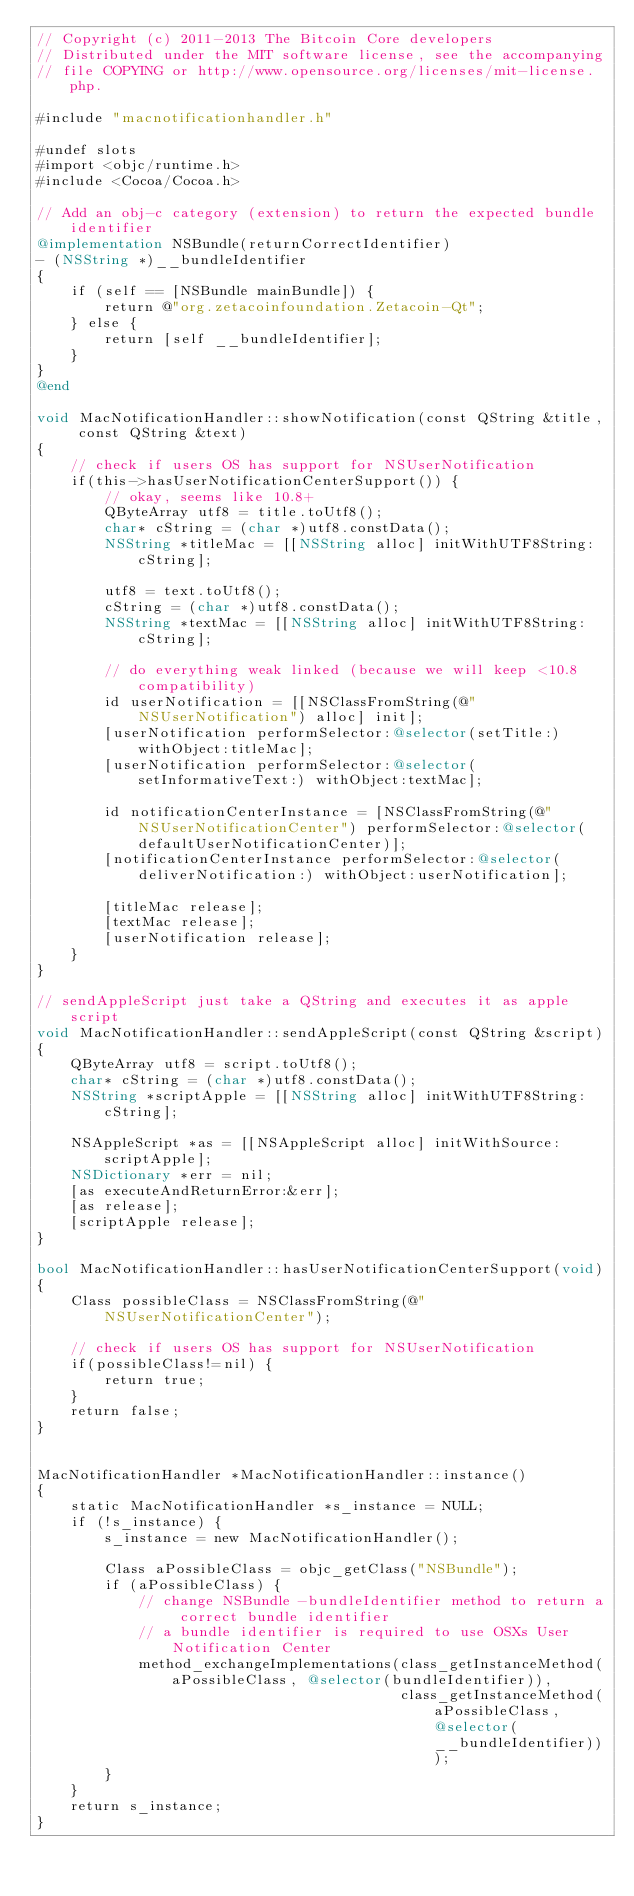Convert code to text. <code><loc_0><loc_0><loc_500><loc_500><_ObjectiveC_>// Copyright (c) 2011-2013 The Bitcoin Core developers
// Distributed under the MIT software license, see the accompanying
// file COPYING or http://www.opensource.org/licenses/mit-license.php.

#include "macnotificationhandler.h"

#undef slots
#import <objc/runtime.h>
#include <Cocoa/Cocoa.h>

// Add an obj-c category (extension) to return the expected bundle identifier
@implementation NSBundle(returnCorrectIdentifier)
- (NSString *)__bundleIdentifier
{
    if (self == [NSBundle mainBundle]) {
        return @"org.zetacoinfoundation.Zetacoin-Qt";
    } else {
        return [self __bundleIdentifier];
    }
}
@end

void MacNotificationHandler::showNotification(const QString &title, const QString &text)
{
    // check if users OS has support for NSUserNotification
    if(this->hasUserNotificationCenterSupport()) {
        // okay, seems like 10.8+
        QByteArray utf8 = title.toUtf8();
        char* cString = (char *)utf8.constData();
        NSString *titleMac = [[NSString alloc] initWithUTF8String:cString];

        utf8 = text.toUtf8();
        cString = (char *)utf8.constData();
        NSString *textMac = [[NSString alloc] initWithUTF8String:cString];

        // do everything weak linked (because we will keep <10.8 compatibility)
        id userNotification = [[NSClassFromString(@"NSUserNotification") alloc] init];
        [userNotification performSelector:@selector(setTitle:) withObject:titleMac];
        [userNotification performSelector:@selector(setInformativeText:) withObject:textMac];

        id notificationCenterInstance = [NSClassFromString(@"NSUserNotificationCenter") performSelector:@selector(defaultUserNotificationCenter)];
        [notificationCenterInstance performSelector:@selector(deliverNotification:) withObject:userNotification];

        [titleMac release];
        [textMac release];
        [userNotification release];
    }
}

// sendAppleScript just take a QString and executes it as apple script
void MacNotificationHandler::sendAppleScript(const QString &script)
{
    QByteArray utf8 = script.toUtf8();
    char* cString = (char *)utf8.constData();
    NSString *scriptApple = [[NSString alloc] initWithUTF8String:cString];

    NSAppleScript *as = [[NSAppleScript alloc] initWithSource:scriptApple];
    NSDictionary *err = nil;
    [as executeAndReturnError:&err];
    [as release];
    [scriptApple release];
}

bool MacNotificationHandler::hasUserNotificationCenterSupport(void)
{
    Class possibleClass = NSClassFromString(@"NSUserNotificationCenter");

    // check if users OS has support for NSUserNotification
    if(possibleClass!=nil) {
        return true;
    }
    return false;
}


MacNotificationHandler *MacNotificationHandler::instance()
{
    static MacNotificationHandler *s_instance = NULL;
    if (!s_instance) {
        s_instance = new MacNotificationHandler();
        
        Class aPossibleClass = objc_getClass("NSBundle");
        if (aPossibleClass) {
            // change NSBundle -bundleIdentifier method to return a correct bundle identifier
            // a bundle identifier is required to use OSXs User Notification Center
            method_exchangeImplementations(class_getInstanceMethod(aPossibleClass, @selector(bundleIdentifier)),
                                           class_getInstanceMethod(aPossibleClass, @selector(__bundleIdentifier)));
        }
    }
    return s_instance;
}
</code> 